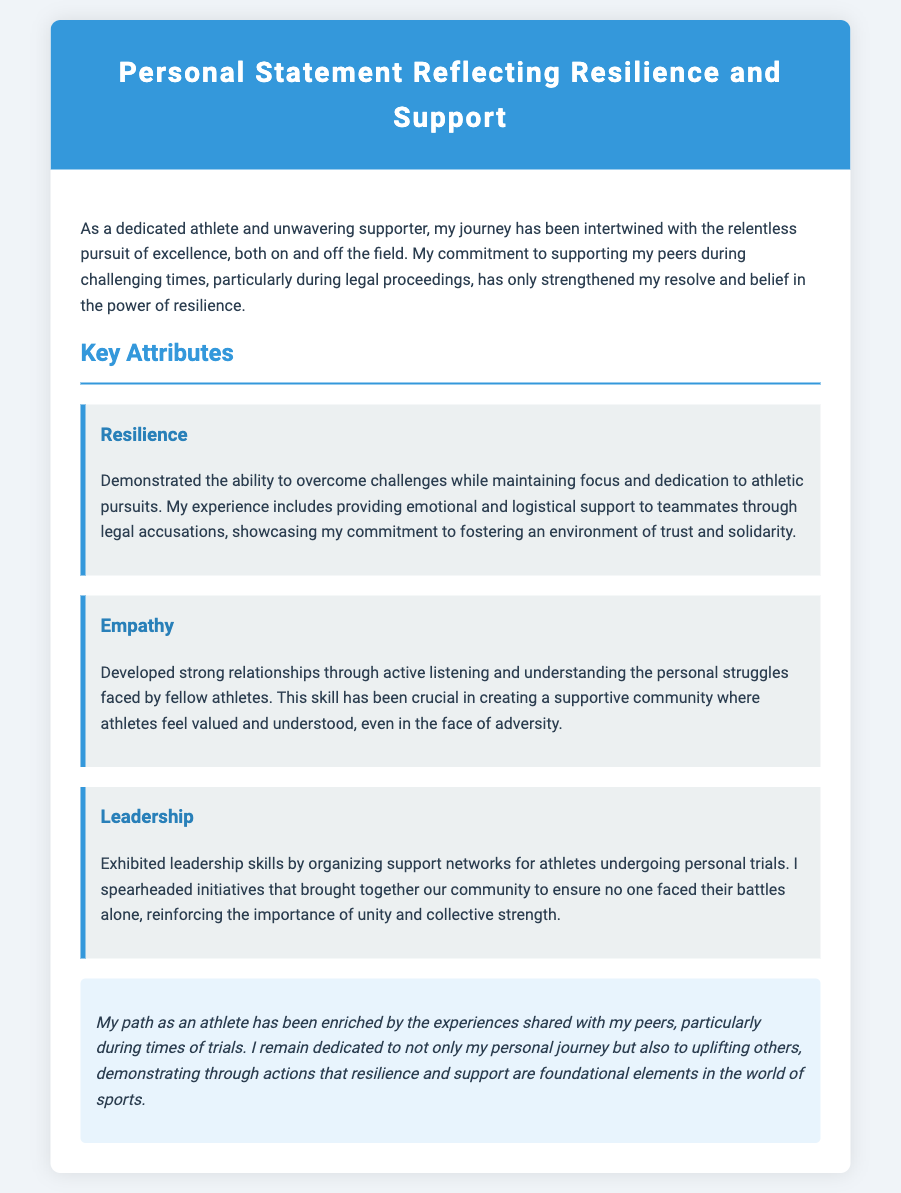what is the title of the document? The title is presented at the top of the document and is clearly labeled.
Answer: Personal Statement Reflecting Resilience and Support how many key attributes are listed in the document? The document explicitly lists three key attributes under the corresponding section.
Answer: 3 what is one of the key attributes mentioned? The document includes multiple key attributes, any of which would be an acceptable answer.
Answer: Resilience who is the audience of this personal statement? The audience of this document can be inferred to be peers, supporters, or evaluators in the athletic community.
Answer: peers what is the purpose of the personal statement? The purpose can be deduced from the content, reflecting the author's experiences and support for others.
Answer: To reflect resilience and support how does the author demonstrate empathy? Empathy is illustrated through the author's active listening and understanding of struggles faced by athletes.
Answer: Active listening and understanding what kind of initiatives did the author organize? The document describes efforts to build a strong community among athletes facing challenges.
Answer: Support networks what is emphasized as a foundational element in sports? The conclusion of the document underscores important themes related to support and individual journeys.
Answer: Resilience and support 